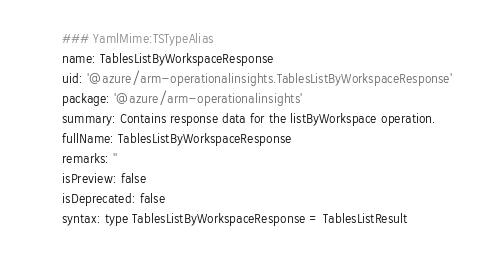<code> <loc_0><loc_0><loc_500><loc_500><_YAML_>### YamlMime:TSTypeAlias
name: TablesListByWorkspaceResponse
uid: '@azure/arm-operationalinsights.TablesListByWorkspaceResponse'
package: '@azure/arm-operationalinsights'
summary: Contains response data for the listByWorkspace operation.
fullName: TablesListByWorkspaceResponse
remarks: ''
isPreview: false
isDeprecated: false
syntax: type TablesListByWorkspaceResponse = TablesListResult
</code> 